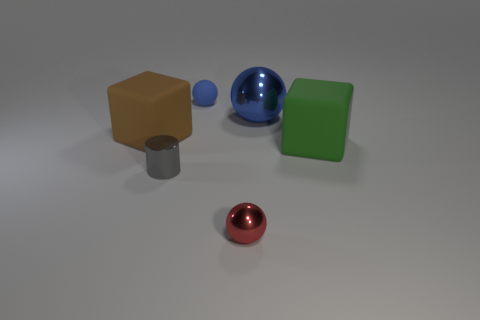Add 2 small red objects. How many objects exist? 8 Subtract all small red balls. How many balls are left? 2 Subtract 1 balls. How many balls are left? 2 Subtract all red spheres. How many spheres are left? 2 Subtract all cylinders. How many objects are left? 5 Subtract all cyan blocks. Subtract all gray spheres. How many blocks are left? 2 Subtract all brown cylinders. How many green blocks are left? 1 Subtract all tiny green matte objects. Subtract all big brown rubber objects. How many objects are left? 5 Add 3 large metal objects. How many large metal objects are left? 4 Add 1 large red spheres. How many large red spheres exist? 1 